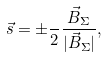Convert formula to latex. <formula><loc_0><loc_0><loc_500><loc_500>\vec { s } = \pm \frac { } { 2 } \frac { \vec { B } _ { \Sigma } } { | \vec { B } _ { \Sigma } | } ,</formula> 